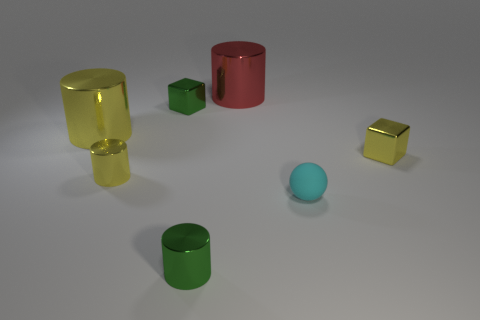What number of small yellow metal objects are behind the yellow metallic object that is on the right side of the red cylinder?
Offer a very short reply. 0. There is a yellow shiny object that is on the right side of the tiny yellow object left of the cylinder that is behind the green metal block; what size is it?
Make the answer very short. Small. What is the color of the rubber sphere that is to the right of the green object that is to the right of the small green cube?
Your response must be concise. Cyan. What number of other things are made of the same material as the large yellow object?
Your answer should be compact. 5. How many other objects are the same color as the matte sphere?
Provide a short and direct response. 0. What material is the cube that is to the left of the small cylinder in front of the small cyan matte ball?
Your response must be concise. Metal. Are there any big yellow metallic blocks?
Offer a terse response. No. There is a shiny cube that is to the right of the metal cylinder to the right of the tiny green cylinder; how big is it?
Offer a terse response. Small. Is the number of metallic blocks that are to the right of the ball greater than the number of cyan spheres on the left side of the red metallic cylinder?
Make the answer very short. Yes. What number of spheres are either small cyan things or tiny gray matte things?
Offer a very short reply. 1. 